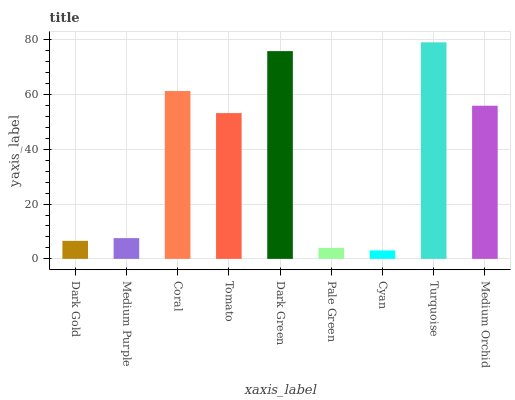Is Cyan the minimum?
Answer yes or no. Yes. Is Turquoise the maximum?
Answer yes or no. Yes. Is Medium Purple the minimum?
Answer yes or no. No. Is Medium Purple the maximum?
Answer yes or no. No. Is Medium Purple greater than Dark Gold?
Answer yes or no. Yes. Is Dark Gold less than Medium Purple?
Answer yes or no. Yes. Is Dark Gold greater than Medium Purple?
Answer yes or no. No. Is Medium Purple less than Dark Gold?
Answer yes or no. No. Is Tomato the high median?
Answer yes or no. Yes. Is Tomato the low median?
Answer yes or no. Yes. Is Coral the high median?
Answer yes or no. No. Is Turquoise the low median?
Answer yes or no. No. 